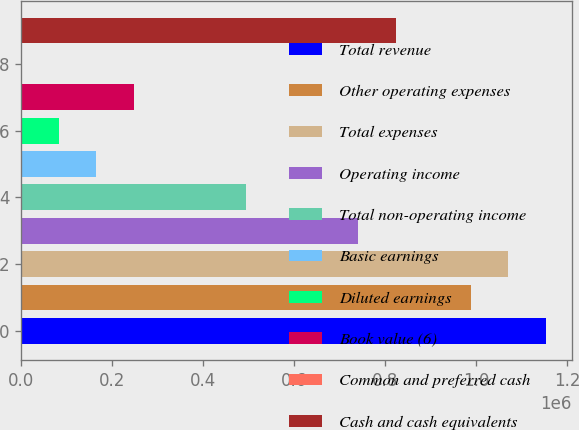Convert chart. <chart><loc_0><loc_0><loc_500><loc_500><bar_chart><fcel>Total revenue<fcel>Other operating expenses<fcel>Total expenses<fcel>Operating income<fcel>Total non-operating income<fcel>Basic earnings<fcel>Diluted earnings<fcel>Book value (6)<fcel>Common and preferred cash<fcel>Cash and cash equivalents<nl><fcel>1.1532e+06<fcel>988460<fcel>1.07083e+06<fcel>741346<fcel>494231<fcel>164746<fcel>82374.5<fcel>247117<fcel>3.12<fcel>823717<nl></chart> 